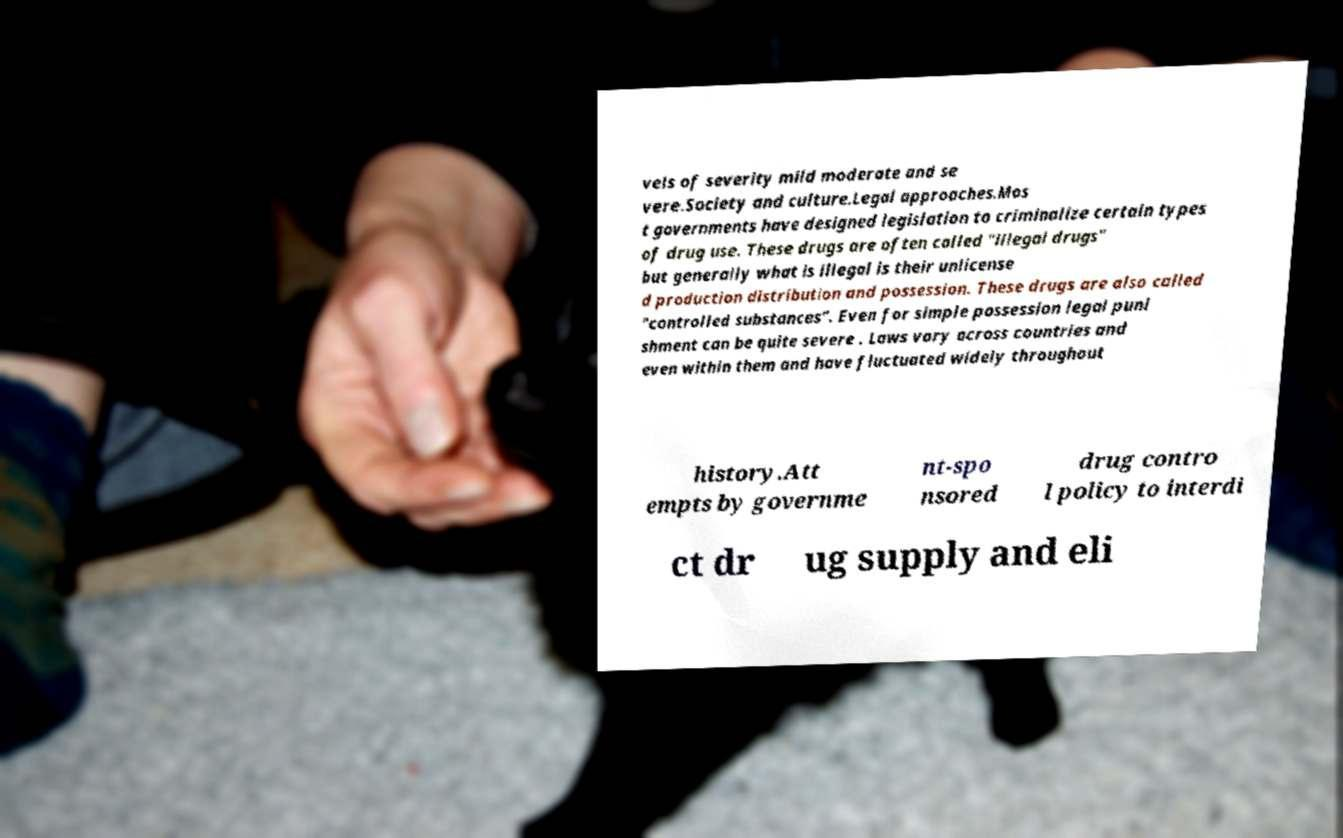Can you accurately transcribe the text from the provided image for me? vels of severity mild moderate and se vere.Society and culture.Legal approaches.Mos t governments have designed legislation to criminalize certain types of drug use. These drugs are often called "illegal drugs" but generally what is illegal is their unlicense d production distribution and possession. These drugs are also called "controlled substances". Even for simple possession legal puni shment can be quite severe . Laws vary across countries and even within them and have fluctuated widely throughout history.Att empts by governme nt-spo nsored drug contro l policy to interdi ct dr ug supply and eli 